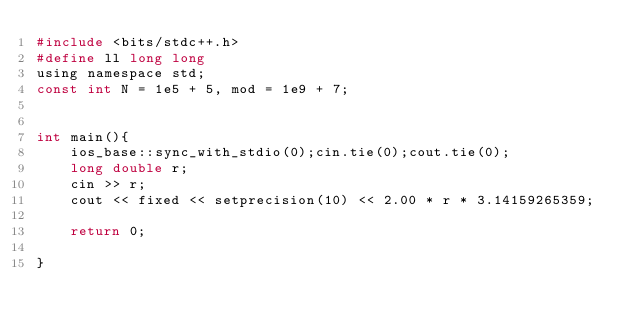<code> <loc_0><loc_0><loc_500><loc_500><_C_>#include <bits/stdc++.h>
#define ll long long
using namespace std;
const int N = 1e5 + 5, mod = 1e9 + 7;


int main(){
    ios_base::sync_with_stdio(0);cin.tie(0);cout.tie(0);
    long double r;
    cin >> r;
    cout << fixed << setprecision(10) << 2.00 * r * 3.14159265359;

    return 0;

}


</code> 